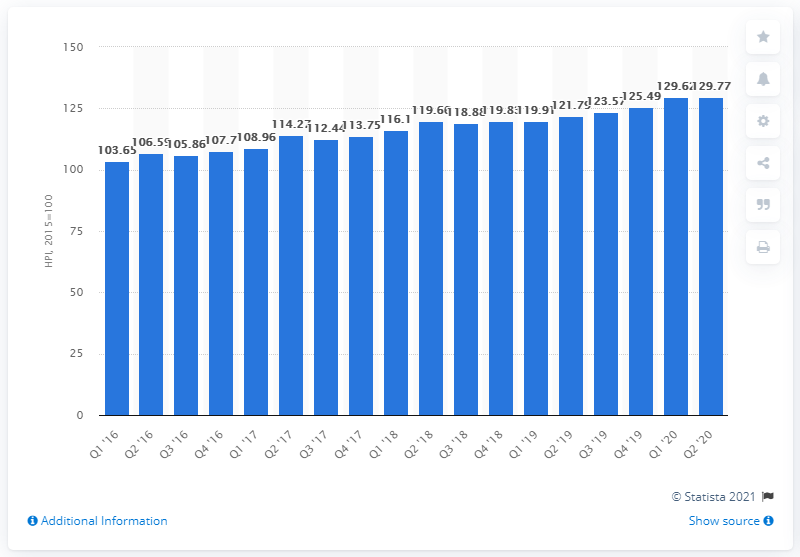Point out several critical features in this image. In June 2020, the house price index in Romania was 129.77. 